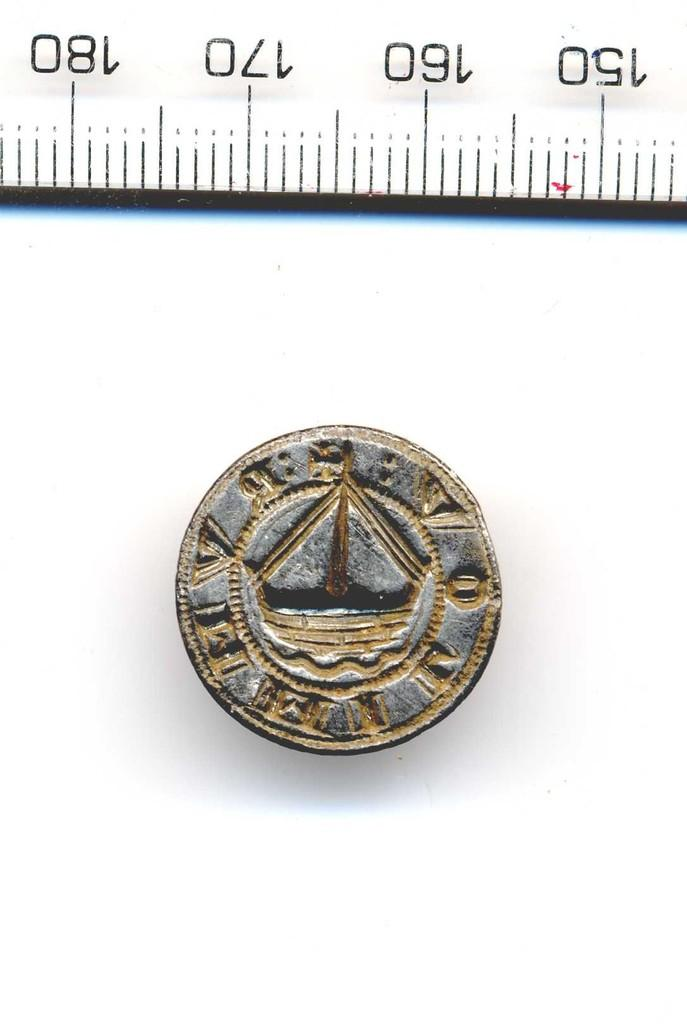<image>
Provide a brief description of the given image. Small piece of tarnished metal embossed with a boat in the center with a ruler at top numbering the sequence 150,160,170,180. 